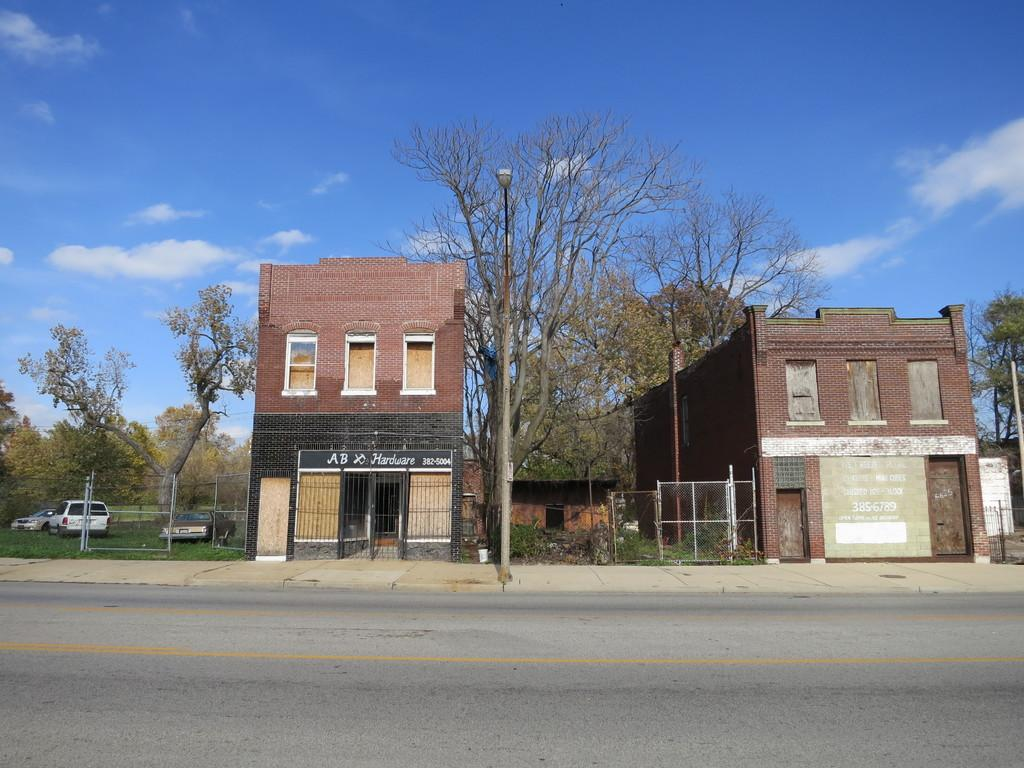What is in the foreground of the image? There is a road in the foreground of the image. What can be seen in the background of the image? There are trees, buildings, fencing, and vehicles in the background of the image. What is visible at the top of the image? The sky is visible at the top of the image. Can you describe the sky in the image? The sky is visible, and there is a cloud in the sky. What color is the shirt worn by the ear in the image? There is no shirt or ear present in the image. 